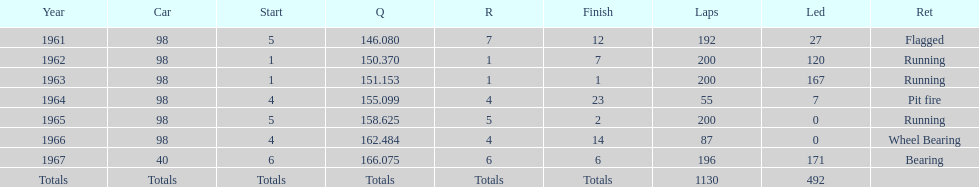How many consecutive years did parnelli place in the top 5? 5. 